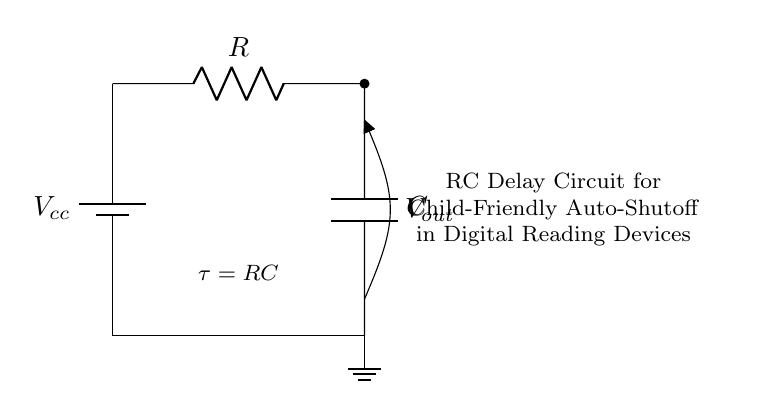What components are present in the circuit? The circuit contains a battery, resistor, and capacitor, which are clearly labeled in the diagram. The battery is at the top, followed by the resistor next to it, and then the capacitor is at the bottom.
Answer: Battery, Resistor, Capacitor What does the symbol “C” represent? The symbol "C" indicates a capacitor in the circuit. It is commonly used to represent the component that stores electrical energy in an electric field.
Answer: Capacitor What is the function of the resistor in this circuit? The resistor's role is to limit the current flowing through the circuit, affecting the charging rate of the capacitor, which ultimately influences the time delay feature.
Answer: Limit current How is the auto-shutoff feature activated? The auto-shutoff feature is activated when the capacitor charges to a certain voltage level, resulting in a change in output voltage, which can signal the device to turn off. This is due to the RC time constant controlling the charge behavior of the capacitor.
Answer: Voltage change What is the time constant formula for this circuit? The time constant formula for an RC circuit is denoted by the symbol "τ" and is represented as "τ = RC", linking the resistance and capacitance together to determine the time it takes for the capacitor to charge or discharge.
Answer: τ = RC What is the effect of increasing the capacitance on the time delay? Increasing the capacitance will increase the time constant τ, which results in a longer time delay for the auto-shutoff feature, as the capacitor takes more time to charge to a specified voltage level.
Answer: Longer delay 